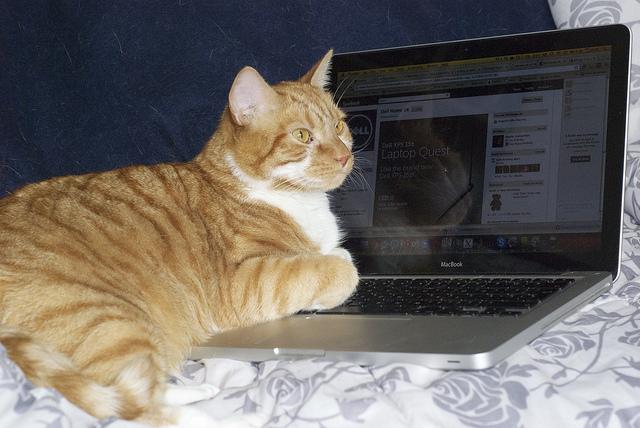How many cats are there?
Concise answer only. 1. What computer logo can be seen on the monitor's screen?
Answer briefly. Dell. What color cat is this?
Keep it brief. Orange. 